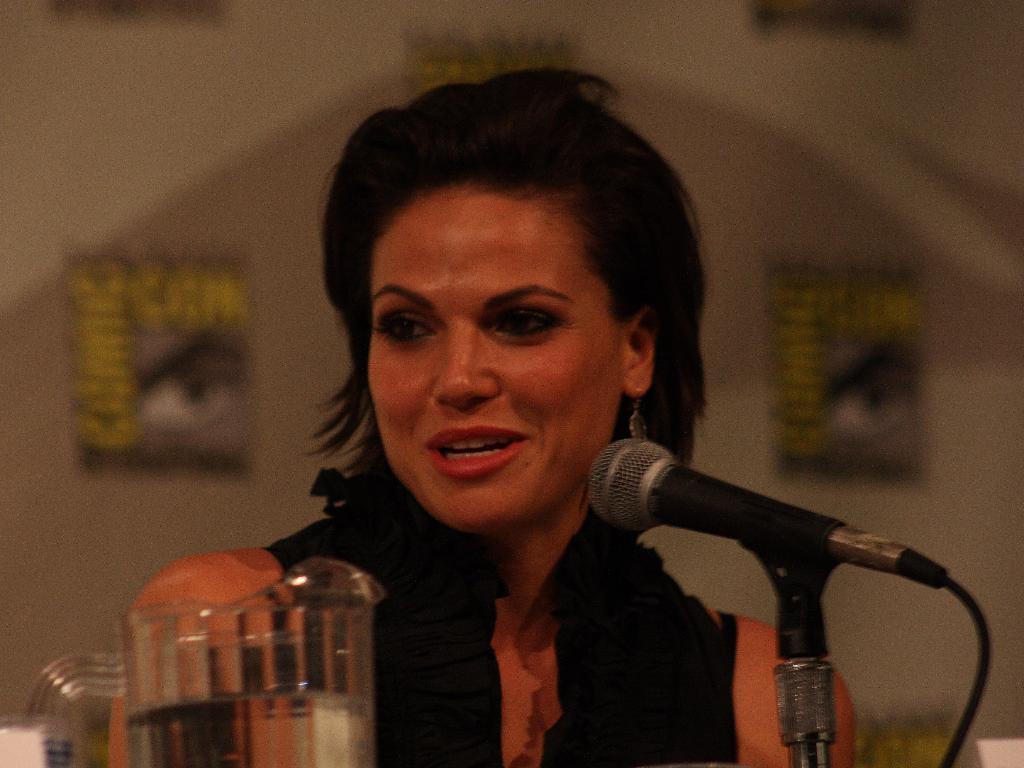Describe this image in one or two sentences. In this image in the front there is a jar and there is a mic. In the center there is a woman speaking on the mic. In the background there are posters on the wall with some text written on it. 